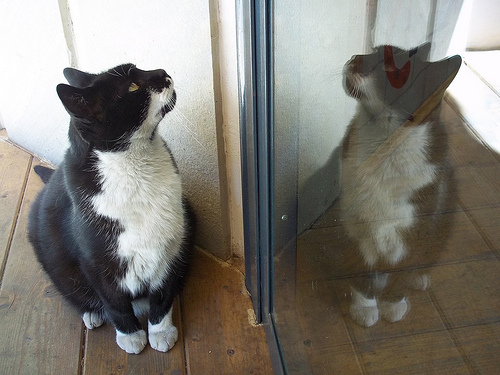<image>
Is there a cat on the relection? No. The cat is not positioned on the relection. They may be near each other, but the cat is not supported by or resting on top of the relection. Where is the cat in relation to the wall? Is it to the right of the wall? No. The cat is not to the right of the wall. The horizontal positioning shows a different relationship. 